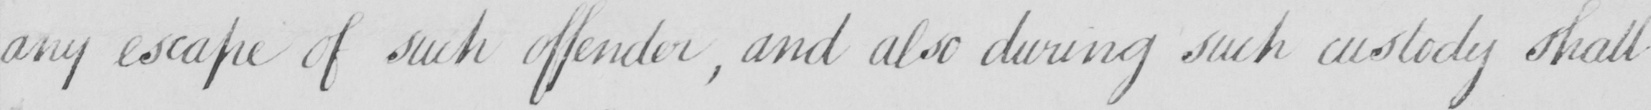What does this handwritten line say? any escape of such offender  , and also during such custody shall 